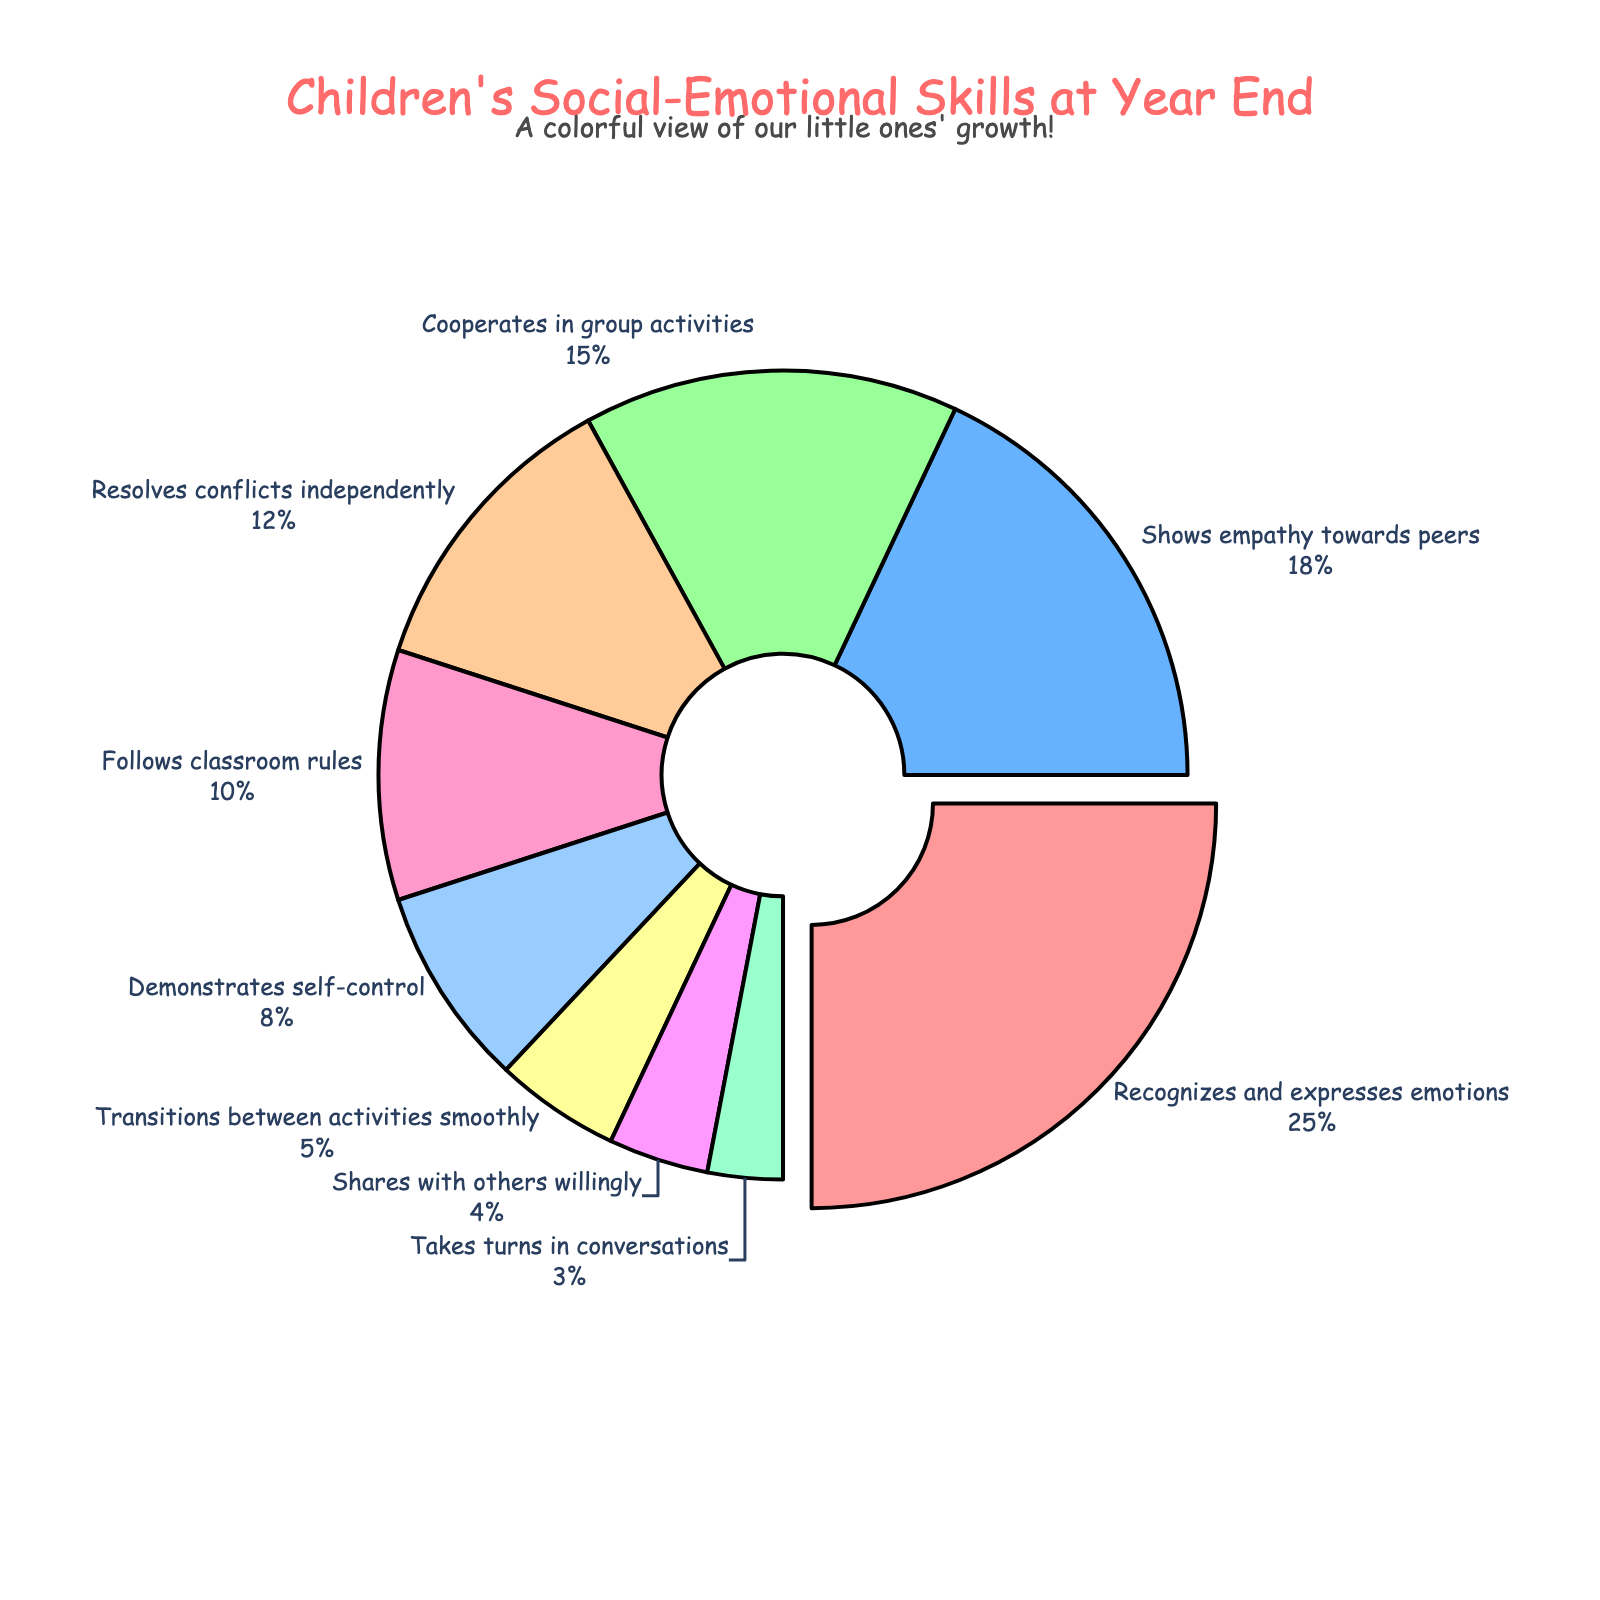Which skill is the most commonly displayed by children at the end of the school year? The figure indicates that "Recognizes and expresses emotions" has the largest segment of the pie chart, shown with the most pulled-out section.
Answer: Recognizes and expresses emotions What is the combined percentage of children who show empathy towards peers and cooperate in group activities? The figure shows that 18% of children show empathy towards peers and 15% cooperate in group activities. Adding these together, 18 + 15 = 33%.
Answer: 33% Which skill is exhibited by a smaller proportion of children, "Demonstrates self-control" or "Follows classroom rules"? By comparing the pie chart segments, "Demonstrates self-control" (8%) is shown by fewer children compared to "Follows classroom rules" (10%).
Answer: Demonstrates self-control How much more frequently do children "Recognize and express emotions" compared to those who "Transition between activities smoothly"? From the chart, 25% of children recognize and express emotions while 5% transition between activities smoothly. The difference is 25 - 5 = 20%.
Answer: 20% What is the total percentage of children who either "Shares with others willingly" or "Takes turns in conversations"? According to the figure, 4% of children share willingly and 3% take turns in conversations. Adding these, 4 + 3 = 7%.
Answer: 7% Which two skills have the most similar proportions displayed by the children? From the pie chart, "Shares with others willingly" (4%) and "Takes turns in conversations" (3%) have very close percentages. The difference between these two is only 1%.
Answer: Shares with others willingly and Takes turns in conversations If the pie chart was rotated such that "Resolves conflicts independently" starts at 0 degrees, which skill will be positioned at the top of the chart? With "Resolves conflicts independently" occupying 12%, the next segments after a total of 48% rotation include "Follows classroom rules" (10%), "Demonstrates self-control" (8%), and "Transitions between activities smoothly" (5%). Adding these percentages, we find that "Transitions between activities smoothly" reaches just beyond 90 degrees. Thus, "Transitions between activities smoothly" will be near the top.
Answer: Transitions between activities smoothly What is the difference in percentage points between the most and the least displayed skill? The most displayed skill (Recognizes and expresses emotions) is exhibited by 25% and the least displayed skill (Takes turns in conversations) is exhibited by 3%. The difference is 25 - 3 = 22%.
Answer: 22% 